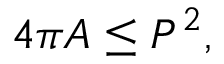<formula> <loc_0><loc_0><loc_500><loc_500>4 \pi A \leq P ^ { 2 } ,</formula> 